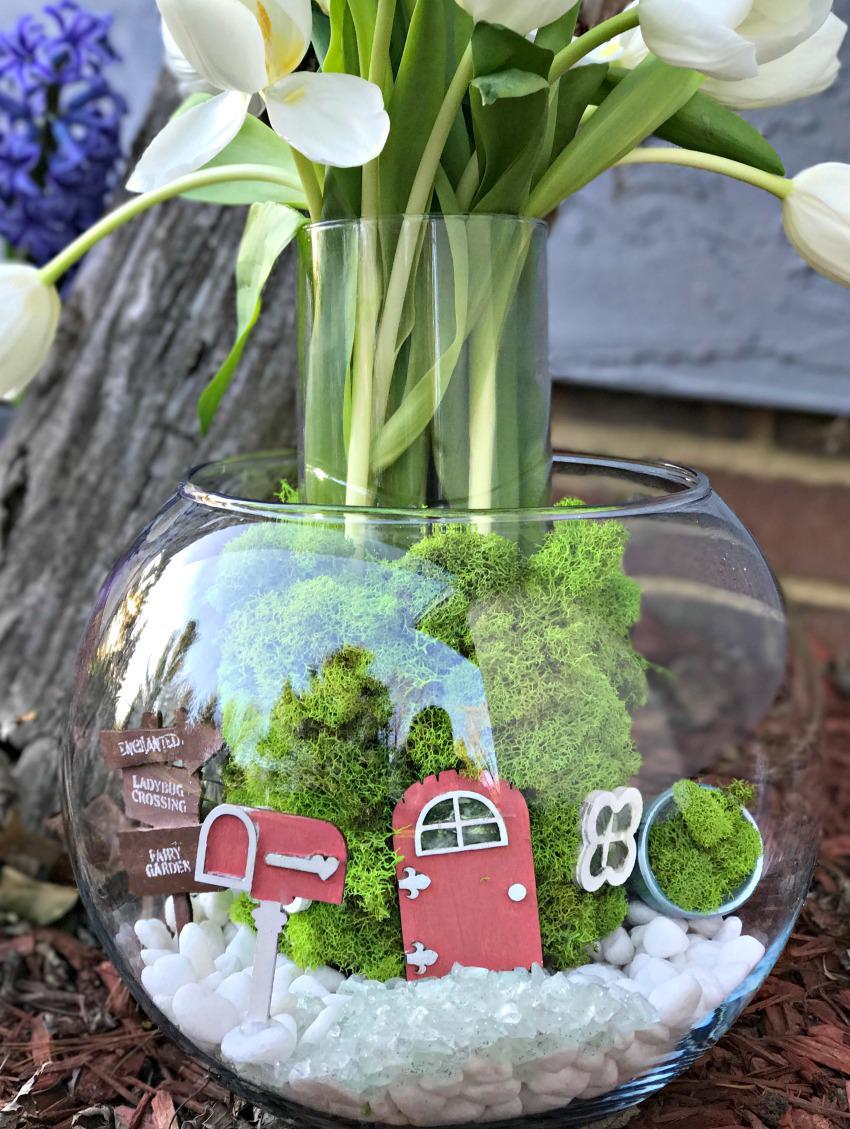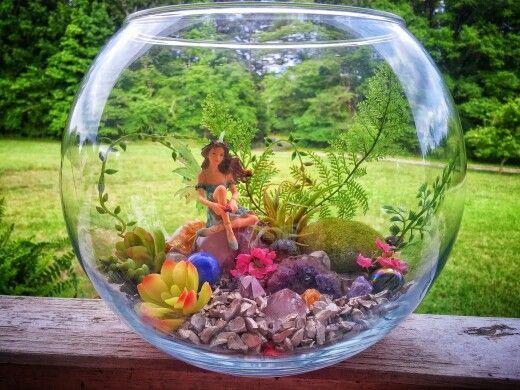The first image is the image on the left, the second image is the image on the right. Evaluate the accuracy of this statement regarding the images: "The right image features a 'fairy garden' terrarium shaped like a fishbowl on its side.". Is it true? Answer yes or no. No. The first image is the image on the left, the second image is the image on the right. Evaluate the accuracy of this statement regarding the images: "In at least on image there is a glass container holding a single sitting female fairy with wings.". Is it true? Answer yes or no. Yes. 